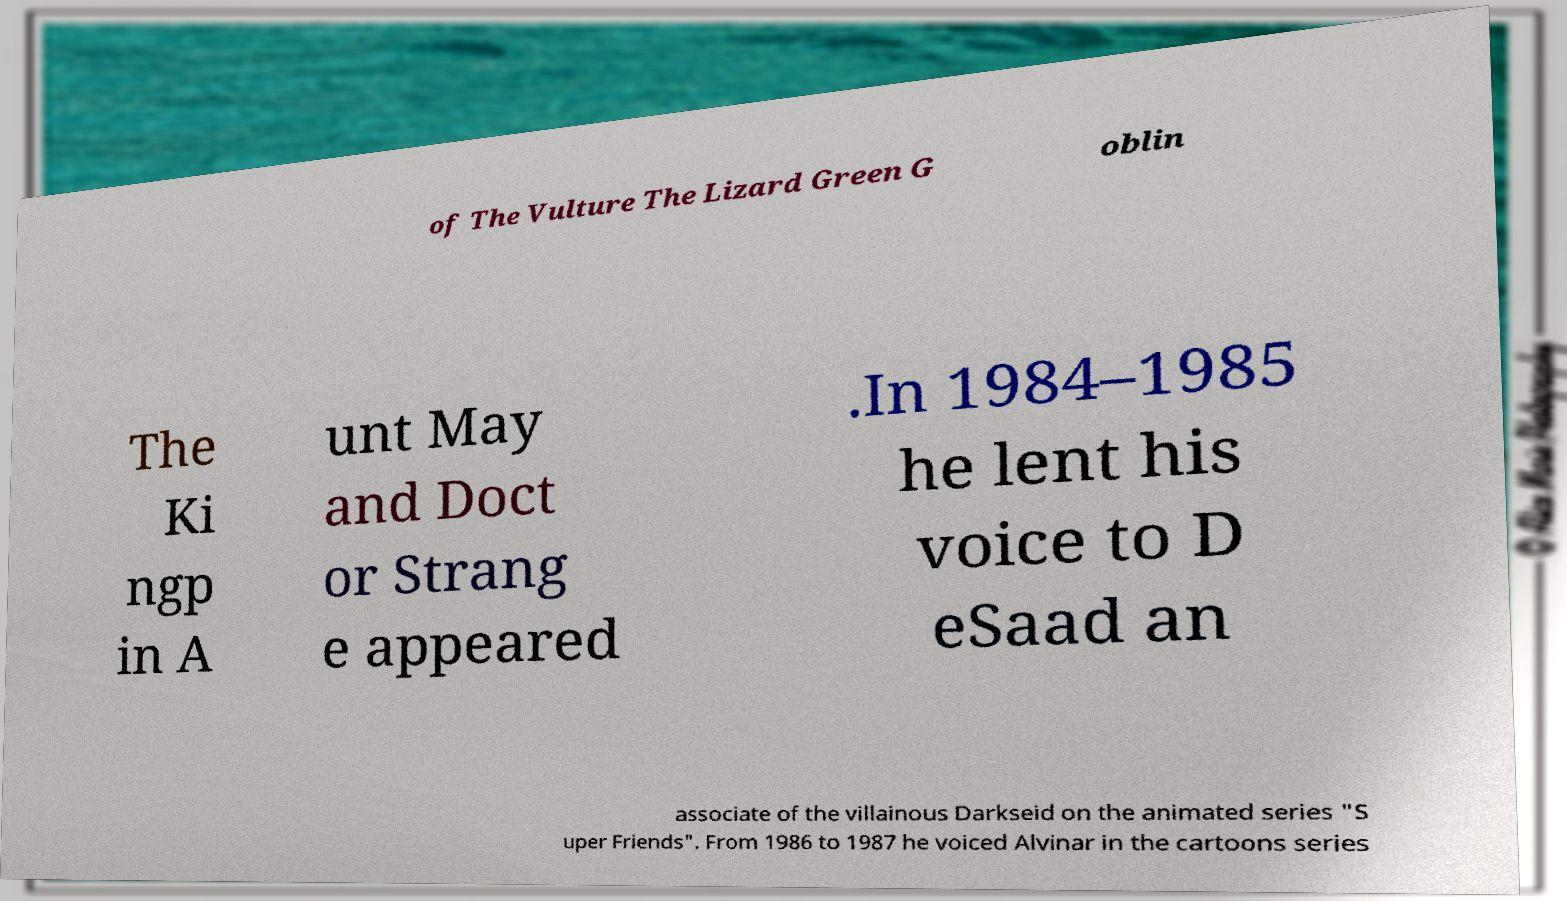There's text embedded in this image that I need extracted. Can you transcribe it verbatim? of The Vulture The Lizard Green G oblin The Ki ngp in A unt May and Doct or Strang e appeared .In 1984–1985 he lent his voice to D eSaad an associate of the villainous Darkseid on the animated series "S uper Friends". From 1986 to 1987 he voiced Alvinar in the cartoons series 